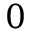<formula> <loc_0><loc_0><loc_500><loc_500>0</formula> 